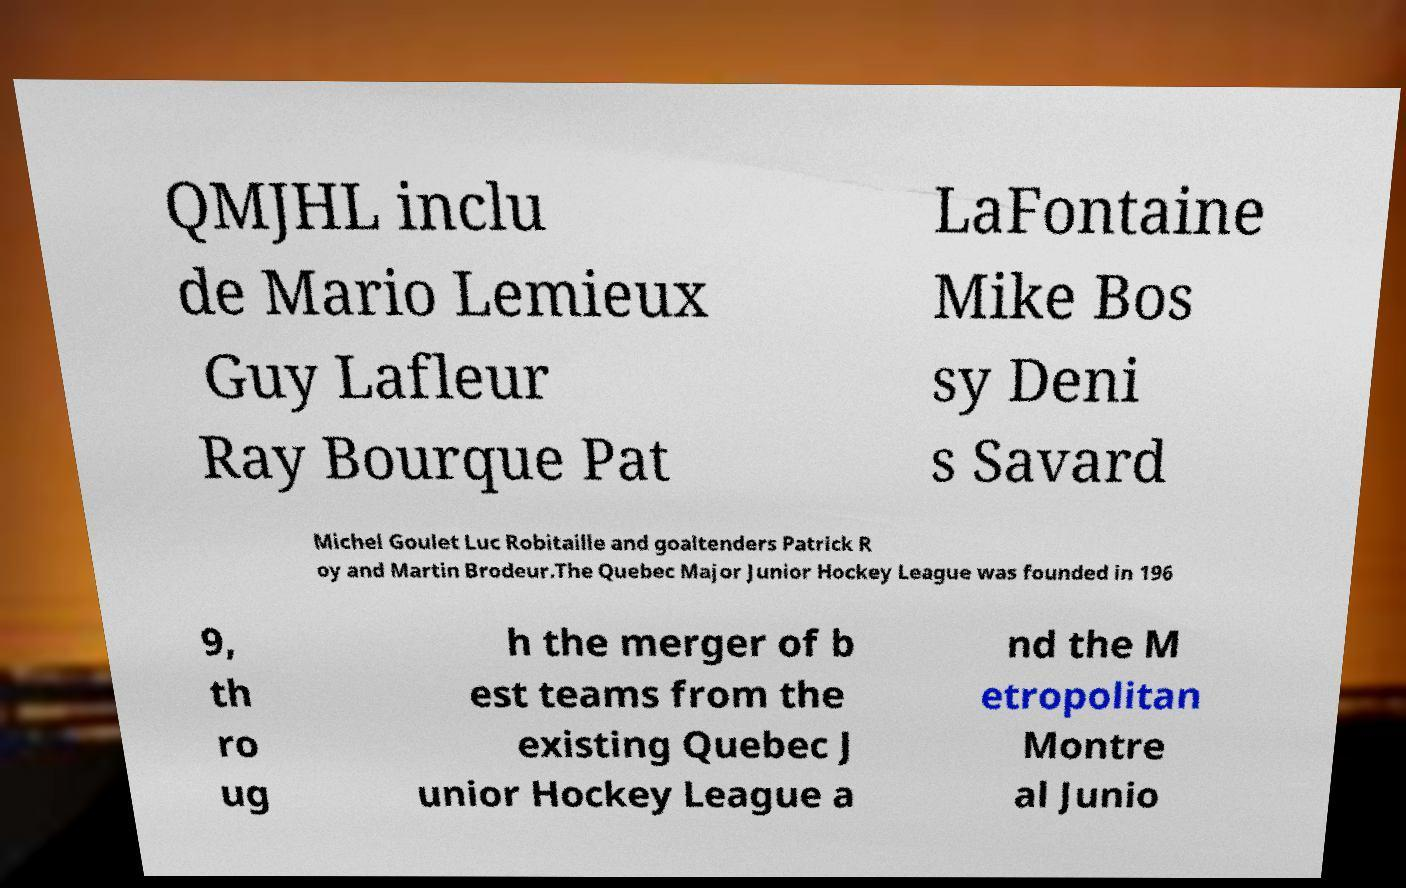Could you assist in decoding the text presented in this image and type it out clearly? QMJHL inclu de Mario Lemieux Guy Lafleur Ray Bourque Pat LaFontaine Mike Bos sy Deni s Savard Michel Goulet Luc Robitaille and goaltenders Patrick R oy and Martin Brodeur.The Quebec Major Junior Hockey League was founded in 196 9, th ro ug h the merger of b est teams from the existing Quebec J unior Hockey League a nd the M etropolitan Montre al Junio 